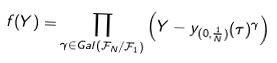<formula> <loc_0><loc_0><loc_500><loc_500>f ( Y ) = \prod _ { \gamma \in G a l ( \mathcal { F } _ { N } / \mathcal { F } _ { 1 } ) } \left ( Y - y _ { ( 0 , \frac { 1 } { N } ) } ( \tau ) ^ { \gamma } \right )</formula> 